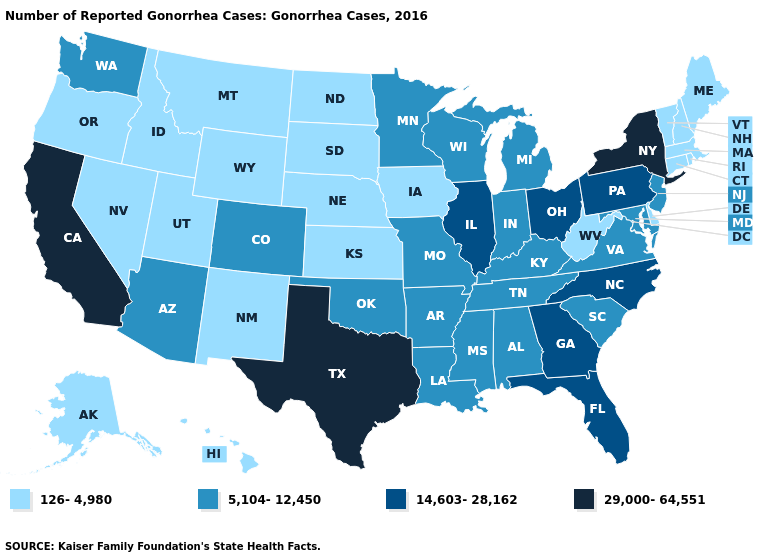What is the value of Massachusetts?
Give a very brief answer. 126-4,980. Does the map have missing data?
Short answer required. No. What is the value of Kentucky?
Write a very short answer. 5,104-12,450. Does South Carolina have the highest value in the USA?
Concise answer only. No. What is the value of California?
Concise answer only. 29,000-64,551. Does Illinois have the highest value in the MidWest?
Give a very brief answer. Yes. Among the states that border Nebraska , does Iowa have the lowest value?
Short answer required. Yes. What is the highest value in the MidWest ?
Answer briefly. 14,603-28,162. Which states have the lowest value in the Northeast?
Write a very short answer. Connecticut, Maine, Massachusetts, New Hampshire, Rhode Island, Vermont. Name the states that have a value in the range 5,104-12,450?
Write a very short answer. Alabama, Arizona, Arkansas, Colorado, Indiana, Kentucky, Louisiana, Maryland, Michigan, Minnesota, Mississippi, Missouri, New Jersey, Oklahoma, South Carolina, Tennessee, Virginia, Washington, Wisconsin. Name the states that have a value in the range 126-4,980?
Keep it brief. Alaska, Connecticut, Delaware, Hawaii, Idaho, Iowa, Kansas, Maine, Massachusetts, Montana, Nebraska, Nevada, New Hampshire, New Mexico, North Dakota, Oregon, Rhode Island, South Dakota, Utah, Vermont, West Virginia, Wyoming. What is the highest value in the USA?
Give a very brief answer. 29,000-64,551. Does California have the highest value in the USA?
Concise answer only. Yes. Does Virginia have a higher value than Mississippi?
Be succinct. No. Which states have the highest value in the USA?
Keep it brief. California, New York, Texas. 